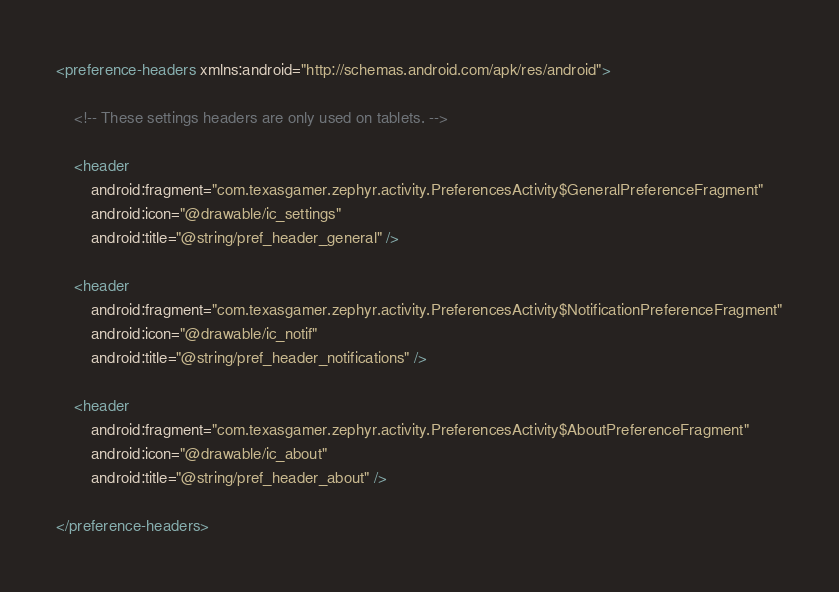<code> <loc_0><loc_0><loc_500><loc_500><_XML_><preference-headers xmlns:android="http://schemas.android.com/apk/res/android">

    <!-- These settings headers are only used on tablets. -->

    <header
        android:fragment="com.texasgamer.zephyr.activity.PreferencesActivity$GeneralPreferenceFragment"
        android:icon="@drawable/ic_settings"
        android:title="@string/pref_header_general" />

    <header
        android:fragment="com.texasgamer.zephyr.activity.PreferencesActivity$NotificationPreferenceFragment"
        android:icon="@drawable/ic_notif"
        android:title="@string/pref_header_notifications" />

    <header
        android:fragment="com.texasgamer.zephyr.activity.PreferencesActivity$AboutPreferenceFragment"
        android:icon="@drawable/ic_about"
        android:title="@string/pref_header_about" />

</preference-headers>
</code> 